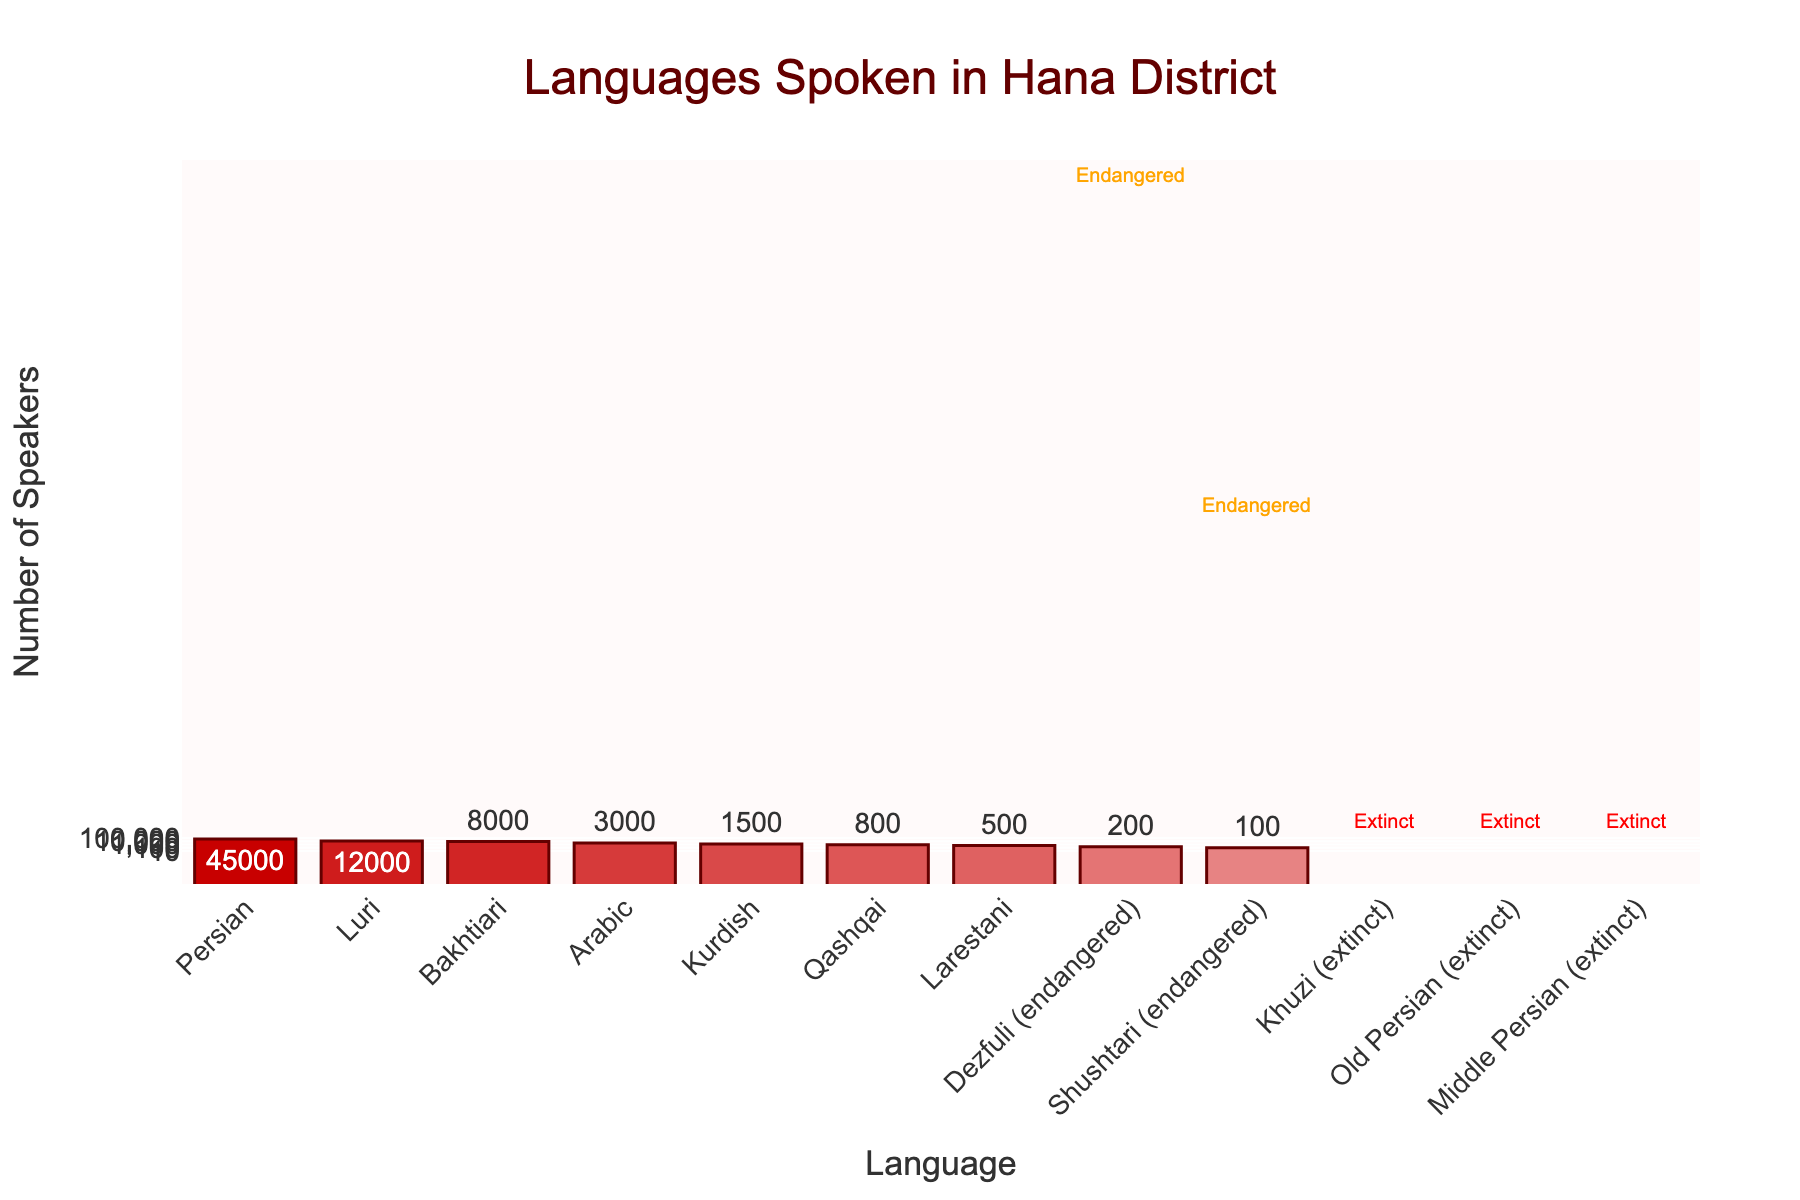Which language has the highest number of speakers in Hana District? The chart shows the languages sorted by the number of speakers in descending order. The highest bar represents the language with the most speakers.
Answer: Persian What is the total number of speakers for endangered languages? The chart lists Dezfuli and Shushtari as endangered languages with 200 and 100 speakers respectively. Summing these values gives 300.
Answer: 300 How many languages have more than 10,000 speakers? The chart has bars for Persian and Luri that are visually higher and surpass the 10,000-speaker mark as indicated on the y-axis.
Answer: 2 Which extinct language(s) are represented in the chart? The chart marks languages with "Extinct" annotations. These are Khuzi, Old Persian, and Middle Persian.
Answer: Khuzi, Old Persian, Middle Persian Which language is spoken by fewer people, Shushtari or Larestani? The bars for Shushtari and Larestani can be compared by height. Shushtari has 100 speakers, and Larestani has 500 speakers, making Shushtari spoken by fewer people.
Answer: Shushtari What is the combined total of speakers for Arabic and Kurdish? The chart shows Arabic has 3000 speakers and Kurdish has 1500 speakers. Adding these numbers gives 4500.
Answer: 4500 How many languages have fewer than 1000 speakers? The chart visually indicates languages with fewer than 1000 speakers, which are Qashqai (800), Larestani (500), Dezfuli (200), and Shushtari (100).
Answer: 4 Is the number of speakers of Bakhtiari greater than or less than the combined total of Qashqai and Arabic speakers? Bakhtiari has 8000 speakers. Qashqai has 800 and Arabic has 3000, making a combined total of 3800. Since 8000 is greater than 3800, Bakhtiari has more speakers.
Answer: Greater What does the color intensity signify in the chart? The color intensity varies according to the number of speakers, with darker shades indicating higher numbers. Persian has the darkest shade, indicating the highest number of speakers, while extinct languages have the lightest shade.
Answer: Number of speakers List the languages with annotations and explain what the annotations mean. The chart includes "Extinct" for Khuzi, Old Persian, and Middle Persian indicating they have no current speakers. "Endangered" annotations are present for Dezfuli and Shushtari, indicating they are at risk of extinction.
Answer: Khuzi, Old Persian, Middle Persian (Extinct); Dezfuli, Shushtari (Endangered) 